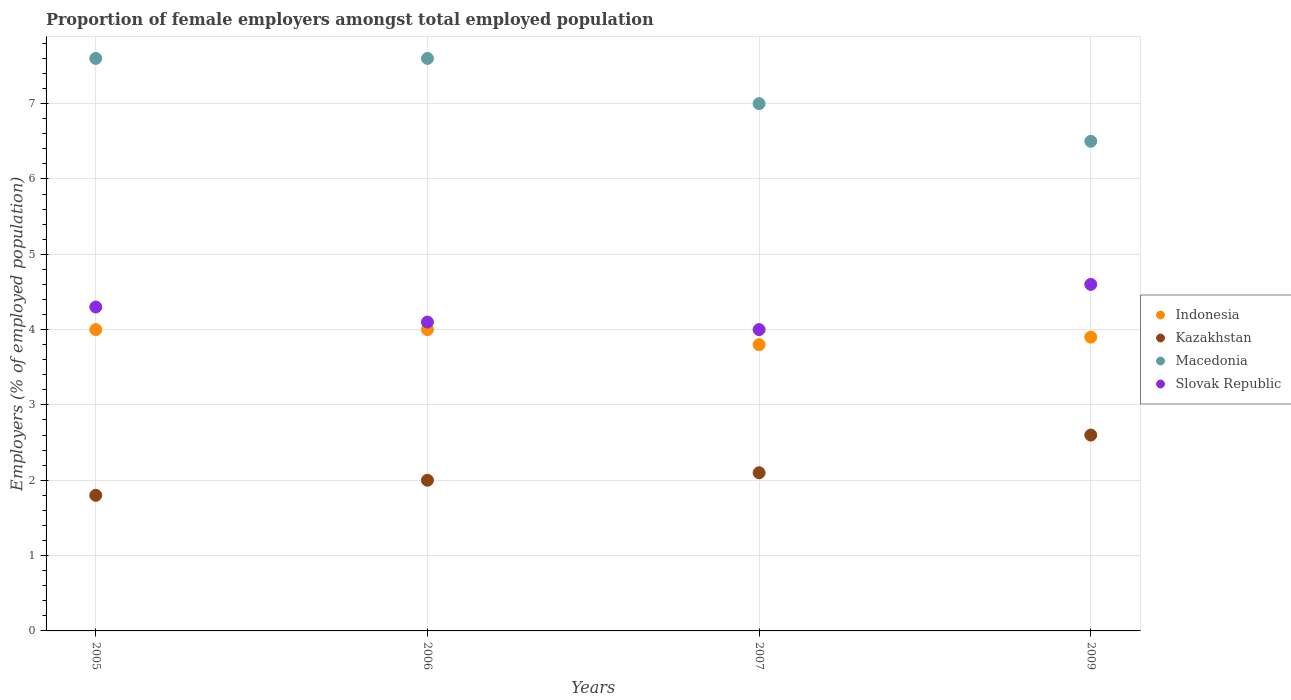Is the number of dotlines equal to the number of legend labels?
Provide a short and direct response. Yes. Across all years, what is the maximum proportion of female employers in Macedonia?
Your response must be concise. 7.6. Across all years, what is the minimum proportion of female employers in Kazakhstan?
Your response must be concise. 1.8. In which year was the proportion of female employers in Indonesia maximum?
Give a very brief answer. 2005. What is the total proportion of female employers in Kazakhstan in the graph?
Give a very brief answer. 8.5. What is the difference between the proportion of female employers in Slovak Republic in 2005 and that in 2006?
Offer a very short reply. 0.2. What is the difference between the proportion of female employers in Kazakhstan in 2006 and the proportion of female employers in Slovak Republic in 2005?
Your answer should be very brief. -2.3. What is the average proportion of female employers in Indonesia per year?
Your answer should be very brief. 3.93. In the year 2009, what is the difference between the proportion of female employers in Macedonia and proportion of female employers in Indonesia?
Make the answer very short. 2.6. In how many years, is the proportion of female employers in Slovak Republic greater than 3.8 %?
Make the answer very short. 4. What is the ratio of the proportion of female employers in Slovak Republic in 2005 to that in 2007?
Keep it short and to the point. 1.08. Is the difference between the proportion of female employers in Macedonia in 2005 and 2007 greater than the difference between the proportion of female employers in Indonesia in 2005 and 2007?
Offer a terse response. Yes. What is the difference between the highest and the second highest proportion of female employers in Kazakhstan?
Make the answer very short. 0.5. What is the difference between the highest and the lowest proportion of female employers in Macedonia?
Give a very brief answer. 1.1. Does the proportion of female employers in Slovak Republic monotonically increase over the years?
Make the answer very short. No. Is the proportion of female employers in Indonesia strictly greater than the proportion of female employers in Kazakhstan over the years?
Your response must be concise. Yes. Is the proportion of female employers in Macedonia strictly less than the proportion of female employers in Slovak Republic over the years?
Provide a succinct answer. No. Are the values on the major ticks of Y-axis written in scientific E-notation?
Your answer should be very brief. No. Does the graph contain grids?
Your response must be concise. Yes. Where does the legend appear in the graph?
Offer a very short reply. Center right. How are the legend labels stacked?
Offer a very short reply. Vertical. What is the title of the graph?
Provide a short and direct response. Proportion of female employers amongst total employed population. What is the label or title of the Y-axis?
Your answer should be compact. Employers (% of employed population). What is the Employers (% of employed population) of Kazakhstan in 2005?
Your answer should be compact. 1.8. What is the Employers (% of employed population) of Macedonia in 2005?
Your answer should be compact. 7.6. What is the Employers (% of employed population) in Slovak Republic in 2005?
Offer a terse response. 4.3. What is the Employers (% of employed population) in Kazakhstan in 2006?
Your answer should be compact. 2. What is the Employers (% of employed population) in Macedonia in 2006?
Provide a succinct answer. 7.6. What is the Employers (% of employed population) of Slovak Republic in 2006?
Make the answer very short. 4.1. What is the Employers (% of employed population) in Indonesia in 2007?
Your response must be concise. 3.8. What is the Employers (% of employed population) of Kazakhstan in 2007?
Offer a very short reply. 2.1. What is the Employers (% of employed population) in Slovak Republic in 2007?
Your answer should be very brief. 4. What is the Employers (% of employed population) of Indonesia in 2009?
Keep it short and to the point. 3.9. What is the Employers (% of employed population) of Kazakhstan in 2009?
Provide a succinct answer. 2.6. What is the Employers (% of employed population) of Macedonia in 2009?
Provide a short and direct response. 6.5. What is the Employers (% of employed population) of Slovak Republic in 2009?
Provide a short and direct response. 4.6. Across all years, what is the maximum Employers (% of employed population) in Kazakhstan?
Offer a terse response. 2.6. Across all years, what is the maximum Employers (% of employed population) of Macedonia?
Provide a short and direct response. 7.6. Across all years, what is the maximum Employers (% of employed population) of Slovak Republic?
Provide a succinct answer. 4.6. Across all years, what is the minimum Employers (% of employed population) in Indonesia?
Provide a short and direct response. 3.8. Across all years, what is the minimum Employers (% of employed population) of Kazakhstan?
Provide a short and direct response. 1.8. Across all years, what is the minimum Employers (% of employed population) of Macedonia?
Provide a succinct answer. 6.5. What is the total Employers (% of employed population) of Indonesia in the graph?
Your answer should be compact. 15.7. What is the total Employers (% of employed population) of Kazakhstan in the graph?
Offer a terse response. 8.5. What is the total Employers (% of employed population) of Macedonia in the graph?
Make the answer very short. 28.7. What is the total Employers (% of employed population) of Slovak Republic in the graph?
Your answer should be very brief. 17. What is the difference between the Employers (% of employed population) in Macedonia in 2005 and that in 2006?
Offer a terse response. 0. What is the difference between the Employers (% of employed population) of Slovak Republic in 2005 and that in 2006?
Ensure brevity in your answer.  0.2. What is the difference between the Employers (% of employed population) of Indonesia in 2005 and that in 2007?
Offer a terse response. 0.2. What is the difference between the Employers (% of employed population) in Macedonia in 2005 and that in 2007?
Give a very brief answer. 0.6. What is the difference between the Employers (% of employed population) of Indonesia in 2005 and that in 2009?
Your answer should be very brief. 0.1. What is the difference between the Employers (% of employed population) of Kazakhstan in 2005 and that in 2009?
Provide a succinct answer. -0.8. What is the difference between the Employers (% of employed population) in Macedonia in 2005 and that in 2009?
Offer a terse response. 1.1. What is the difference between the Employers (% of employed population) of Slovak Republic in 2005 and that in 2009?
Your answer should be very brief. -0.3. What is the difference between the Employers (% of employed population) of Indonesia in 2006 and that in 2007?
Provide a succinct answer. 0.2. What is the difference between the Employers (% of employed population) of Macedonia in 2006 and that in 2007?
Keep it short and to the point. 0.6. What is the difference between the Employers (% of employed population) in Macedonia in 2006 and that in 2009?
Offer a very short reply. 1.1. What is the difference between the Employers (% of employed population) of Slovak Republic in 2006 and that in 2009?
Provide a succinct answer. -0.5. What is the difference between the Employers (% of employed population) of Slovak Republic in 2007 and that in 2009?
Your answer should be very brief. -0.6. What is the difference between the Employers (% of employed population) of Indonesia in 2005 and the Employers (% of employed population) of Kazakhstan in 2006?
Offer a very short reply. 2. What is the difference between the Employers (% of employed population) in Kazakhstan in 2005 and the Employers (% of employed population) in Macedonia in 2006?
Your answer should be compact. -5.8. What is the difference between the Employers (% of employed population) of Macedonia in 2005 and the Employers (% of employed population) of Slovak Republic in 2006?
Provide a short and direct response. 3.5. What is the difference between the Employers (% of employed population) of Indonesia in 2005 and the Employers (% of employed population) of Macedonia in 2007?
Provide a succinct answer. -3. What is the difference between the Employers (% of employed population) in Kazakhstan in 2005 and the Employers (% of employed population) in Slovak Republic in 2007?
Make the answer very short. -2.2. What is the difference between the Employers (% of employed population) in Indonesia in 2005 and the Employers (% of employed population) in Kazakhstan in 2009?
Ensure brevity in your answer.  1.4. What is the difference between the Employers (% of employed population) in Indonesia in 2005 and the Employers (% of employed population) in Macedonia in 2009?
Offer a very short reply. -2.5. What is the difference between the Employers (% of employed population) of Indonesia in 2005 and the Employers (% of employed population) of Slovak Republic in 2009?
Provide a short and direct response. -0.6. What is the difference between the Employers (% of employed population) of Kazakhstan in 2005 and the Employers (% of employed population) of Slovak Republic in 2009?
Provide a short and direct response. -2.8. What is the difference between the Employers (% of employed population) of Indonesia in 2006 and the Employers (% of employed population) of Kazakhstan in 2007?
Your answer should be compact. 1.9. What is the difference between the Employers (% of employed population) of Indonesia in 2006 and the Employers (% of employed population) of Macedonia in 2007?
Offer a very short reply. -3. What is the difference between the Employers (% of employed population) in Kazakhstan in 2006 and the Employers (% of employed population) in Macedonia in 2007?
Your response must be concise. -5. What is the difference between the Employers (% of employed population) in Kazakhstan in 2006 and the Employers (% of employed population) in Slovak Republic in 2007?
Your answer should be very brief. -2. What is the difference between the Employers (% of employed population) of Macedonia in 2006 and the Employers (% of employed population) of Slovak Republic in 2007?
Keep it short and to the point. 3.6. What is the difference between the Employers (% of employed population) of Indonesia in 2006 and the Employers (% of employed population) of Macedonia in 2009?
Your answer should be very brief. -2.5. What is the difference between the Employers (% of employed population) in Indonesia in 2006 and the Employers (% of employed population) in Slovak Republic in 2009?
Offer a very short reply. -0.6. What is the difference between the Employers (% of employed population) of Kazakhstan in 2006 and the Employers (% of employed population) of Macedonia in 2009?
Ensure brevity in your answer.  -4.5. What is the difference between the Employers (% of employed population) of Kazakhstan in 2006 and the Employers (% of employed population) of Slovak Republic in 2009?
Your response must be concise. -2.6. What is the difference between the Employers (% of employed population) of Indonesia in 2007 and the Employers (% of employed population) of Slovak Republic in 2009?
Ensure brevity in your answer.  -0.8. What is the difference between the Employers (% of employed population) of Kazakhstan in 2007 and the Employers (% of employed population) of Macedonia in 2009?
Make the answer very short. -4.4. What is the difference between the Employers (% of employed population) in Macedonia in 2007 and the Employers (% of employed population) in Slovak Republic in 2009?
Offer a terse response. 2.4. What is the average Employers (% of employed population) in Indonesia per year?
Provide a short and direct response. 3.92. What is the average Employers (% of employed population) of Kazakhstan per year?
Provide a short and direct response. 2.12. What is the average Employers (% of employed population) in Macedonia per year?
Give a very brief answer. 7.17. What is the average Employers (% of employed population) in Slovak Republic per year?
Make the answer very short. 4.25. In the year 2005, what is the difference between the Employers (% of employed population) in Kazakhstan and Employers (% of employed population) in Slovak Republic?
Your answer should be very brief. -2.5. In the year 2006, what is the difference between the Employers (% of employed population) in Indonesia and Employers (% of employed population) in Macedonia?
Make the answer very short. -3.6. In the year 2006, what is the difference between the Employers (% of employed population) of Indonesia and Employers (% of employed population) of Slovak Republic?
Offer a terse response. -0.1. In the year 2006, what is the difference between the Employers (% of employed population) of Kazakhstan and Employers (% of employed population) of Slovak Republic?
Offer a very short reply. -2.1. In the year 2006, what is the difference between the Employers (% of employed population) in Macedonia and Employers (% of employed population) in Slovak Republic?
Provide a short and direct response. 3.5. In the year 2007, what is the difference between the Employers (% of employed population) in Indonesia and Employers (% of employed population) in Kazakhstan?
Your response must be concise. 1.7. In the year 2007, what is the difference between the Employers (% of employed population) of Indonesia and Employers (% of employed population) of Slovak Republic?
Offer a very short reply. -0.2. In the year 2007, what is the difference between the Employers (% of employed population) of Kazakhstan and Employers (% of employed population) of Macedonia?
Provide a succinct answer. -4.9. In the year 2007, what is the difference between the Employers (% of employed population) of Kazakhstan and Employers (% of employed population) of Slovak Republic?
Offer a terse response. -1.9. In the year 2009, what is the difference between the Employers (% of employed population) in Indonesia and Employers (% of employed population) in Kazakhstan?
Your response must be concise. 1.3. In the year 2009, what is the difference between the Employers (% of employed population) of Indonesia and Employers (% of employed population) of Macedonia?
Make the answer very short. -2.6. In the year 2009, what is the difference between the Employers (% of employed population) of Kazakhstan and Employers (% of employed population) of Macedonia?
Give a very brief answer. -3.9. In the year 2009, what is the difference between the Employers (% of employed population) in Macedonia and Employers (% of employed population) in Slovak Republic?
Offer a very short reply. 1.9. What is the ratio of the Employers (% of employed population) in Macedonia in 2005 to that in 2006?
Give a very brief answer. 1. What is the ratio of the Employers (% of employed population) in Slovak Republic in 2005 to that in 2006?
Your answer should be very brief. 1.05. What is the ratio of the Employers (% of employed population) in Indonesia in 2005 to that in 2007?
Offer a very short reply. 1.05. What is the ratio of the Employers (% of employed population) of Kazakhstan in 2005 to that in 2007?
Ensure brevity in your answer.  0.86. What is the ratio of the Employers (% of employed population) of Macedonia in 2005 to that in 2007?
Provide a succinct answer. 1.09. What is the ratio of the Employers (% of employed population) of Slovak Republic in 2005 to that in 2007?
Your answer should be compact. 1.07. What is the ratio of the Employers (% of employed population) of Indonesia in 2005 to that in 2009?
Ensure brevity in your answer.  1.03. What is the ratio of the Employers (% of employed population) of Kazakhstan in 2005 to that in 2009?
Provide a succinct answer. 0.69. What is the ratio of the Employers (% of employed population) of Macedonia in 2005 to that in 2009?
Give a very brief answer. 1.17. What is the ratio of the Employers (% of employed population) of Slovak Republic in 2005 to that in 2009?
Your answer should be compact. 0.93. What is the ratio of the Employers (% of employed population) of Indonesia in 2006 to that in 2007?
Give a very brief answer. 1.05. What is the ratio of the Employers (% of employed population) of Macedonia in 2006 to that in 2007?
Your answer should be very brief. 1.09. What is the ratio of the Employers (% of employed population) of Slovak Republic in 2006 to that in 2007?
Your answer should be compact. 1.02. What is the ratio of the Employers (% of employed population) of Indonesia in 2006 to that in 2009?
Ensure brevity in your answer.  1.03. What is the ratio of the Employers (% of employed population) in Kazakhstan in 2006 to that in 2009?
Ensure brevity in your answer.  0.77. What is the ratio of the Employers (% of employed population) of Macedonia in 2006 to that in 2009?
Make the answer very short. 1.17. What is the ratio of the Employers (% of employed population) of Slovak Republic in 2006 to that in 2009?
Give a very brief answer. 0.89. What is the ratio of the Employers (% of employed population) in Indonesia in 2007 to that in 2009?
Your answer should be compact. 0.97. What is the ratio of the Employers (% of employed population) of Kazakhstan in 2007 to that in 2009?
Keep it short and to the point. 0.81. What is the ratio of the Employers (% of employed population) of Slovak Republic in 2007 to that in 2009?
Offer a very short reply. 0.87. What is the difference between the highest and the second highest Employers (% of employed population) of Macedonia?
Offer a very short reply. 0. What is the difference between the highest and the second highest Employers (% of employed population) of Slovak Republic?
Your answer should be compact. 0.3. 